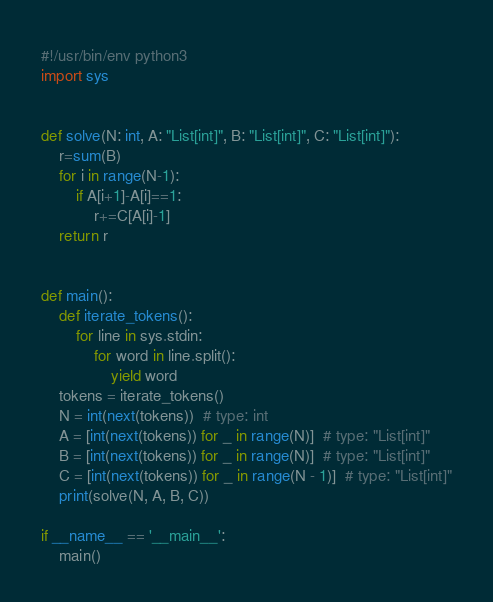Convert code to text. <code><loc_0><loc_0><loc_500><loc_500><_Python_>#!/usr/bin/env python3
import sys


def solve(N: int, A: "List[int]", B: "List[int]", C: "List[int]"):
    r=sum(B)
    for i in range(N-1):
        if A[i+1]-A[i]==1:
            r+=C[A[i]-1]
    return r


def main():
    def iterate_tokens():
        for line in sys.stdin:
            for word in line.split():
                yield word
    tokens = iterate_tokens()
    N = int(next(tokens))  # type: int
    A = [int(next(tokens)) for _ in range(N)]  # type: "List[int]"
    B = [int(next(tokens)) for _ in range(N)]  # type: "List[int]"
    C = [int(next(tokens)) for _ in range(N - 1)]  # type: "List[int]"
    print(solve(N, A, B, C))

if __name__ == '__main__':
    main()
</code> 